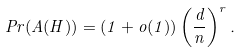<formula> <loc_0><loc_0><loc_500><loc_500>P r ( A ( H ) ) = ( 1 + o ( 1 ) ) \left ( \frac { d } { n } \right ) ^ { r } .</formula> 